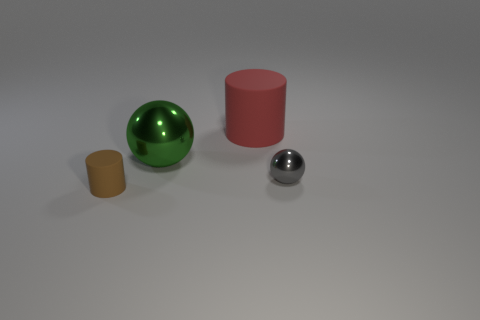What material is the red cylinder that is the same size as the green metal object?
Make the answer very short. Rubber. Are there fewer large matte cylinders behind the large red object than small gray metallic spheres that are right of the green sphere?
Provide a succinct answer. Yes. What shape is the rubber object that is behind the matte object that is in front of the tiny gray ball?
Provide a succinct answer. Cylinder. Are there any big blue balls?
Your answer should be compact. No. There is a cylinder behind the tiny matte object; what is its color?
Ensure brevity in your answer.  Red. Are there any tiny things to the right of the big cylinder?
Provide a succinct answer. Yes. Are there more large shiny spheres than large green metal cylinders?
Offer a terse response. Yes. There is a rubber thing behind the small brown object in front of the tiny metal sphere that is in front of the big green thing; what is its color?
Provide a short and direct response. Red. There is a big sphere that is the same material as the small gray sphere; what color is it?
Make the answer very short. Green. What number of objects are matte things that are in front of the large red cylinder or spheres to the left of the small gray metallic ball?
Give a very brief answer. 2. 